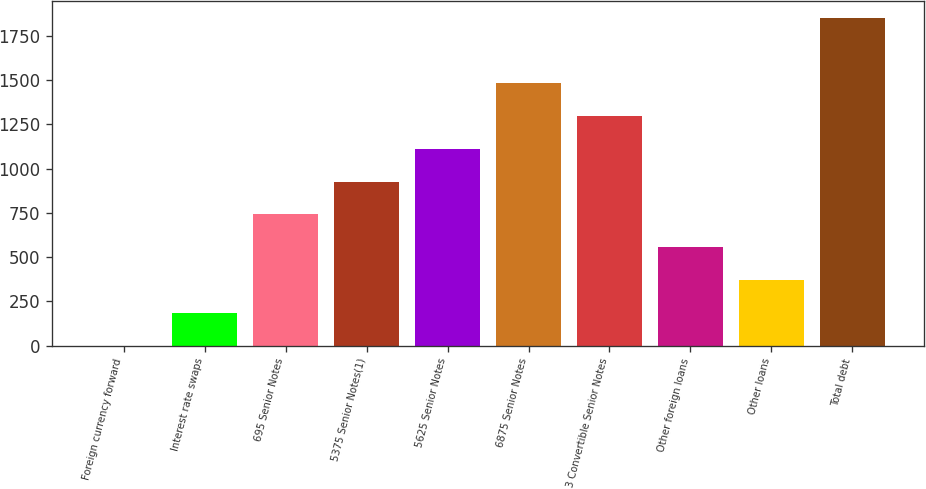<chart> <loc_0><loc_0><loc_500><loc_500><bar_chart><fcel>Foreign currency forward<fcel>Interest rate swaps<fcel>695 Senior Notes<fcel>5375 Senior Notes(1)<fcel>5625 Senior Notes<fcel>6875 Senior Notes<fcel>3 Convertible Senior Notes<fcel>Other foreign loans<fcel>Other loans<fcel>Total debt<nl><fcel>0.1<fcel>185.32<fcel>740.98<fcel>926.2<fcel>1111.42<fcel>1481.86<fcel>1296.64<fcel>555.76<fcel>370.54<fcel>1852.3<nl></chart> 